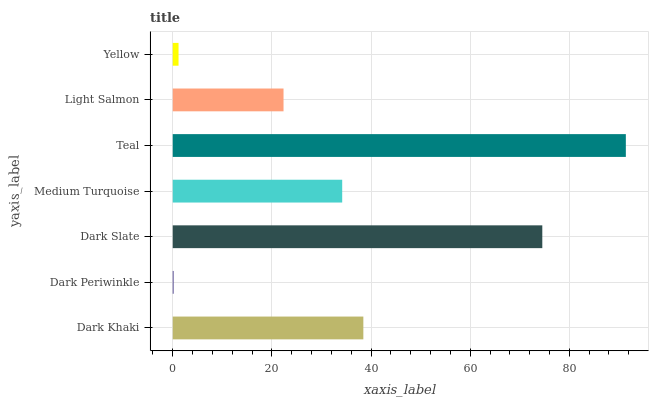Is Dark Periwinkle the minimum?
Answer yes or no. Yes. Is Teal the maximum?
Answer yes or no. Yes. Is Dark Slate the minimum?
Answer yes or no. No. Is Dark Slate the maximum?
Answer yes or no. No. Is Dark Slate greater than Dark Periwinkle?
Answer yes or no. Yes. Is Dark Periwinkle less than Dark Slate?
Answer yes or no. Yes. Is Dark Periwinkle greater than Dark Slate?
Answer yes or no. No. Is Dark Slate less than Dark Periwinkle?
Answer yes or no. No. Is Medium Turquoise the high median?
Answer yes or no. Yes. Is Medium Turquoise the low median?
Answer yes or no. Yes. Is Teal the high median?
Answer yes or no. No. Is Dark Slate the low median?
Answer yes or no. No. 